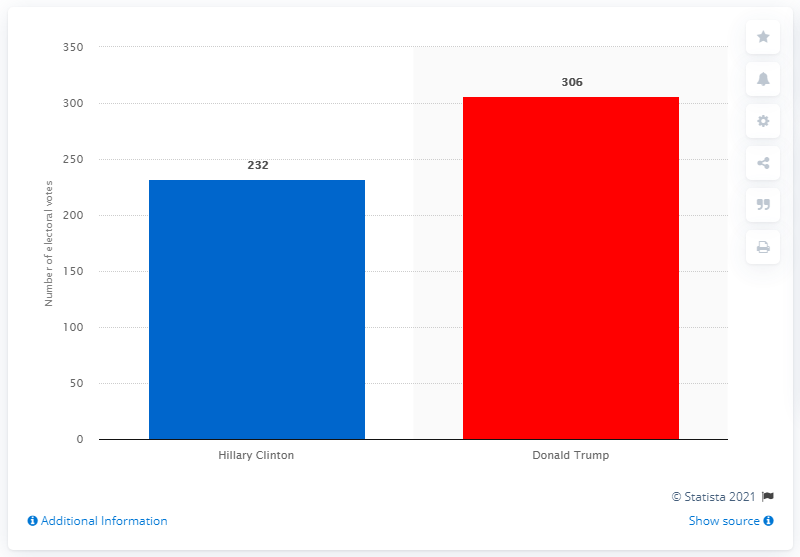Give some essential details in this illustration. Donald Trump's opponent in the 2016 presidential election was Hillary Clinton. Donald Trump won the presidential election with 306 electoral college votes. 